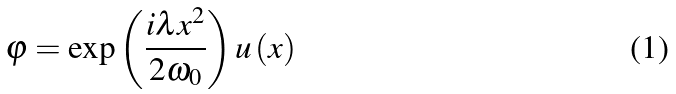<formula> <loc_0><loc_0><loc_500><loc_500>\varphi = \exp \left ( \frac { i \lambda x ^ { 2 } } { 2 \omega _ { 0 } } \right ) u \left ( x \right )</formula> 